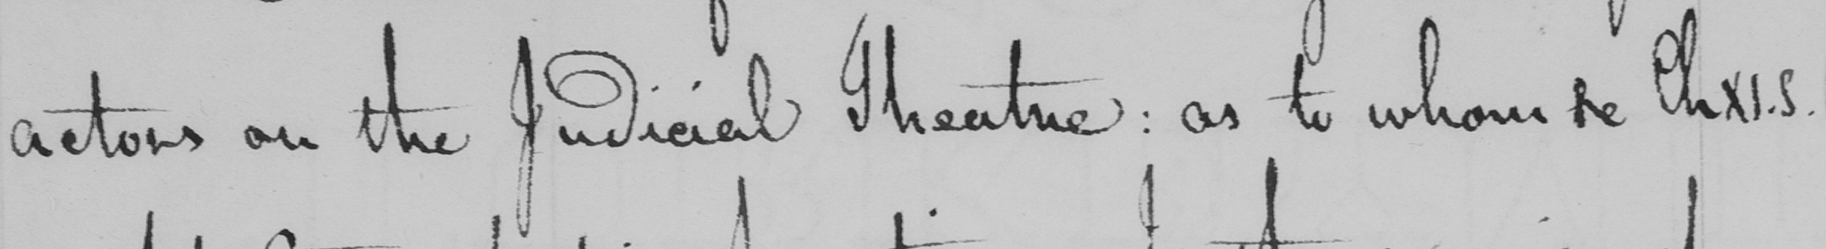Can you tell me what this handwritten text says? actors on the Judicial Theatre :  as to whom Se ChXI.5 